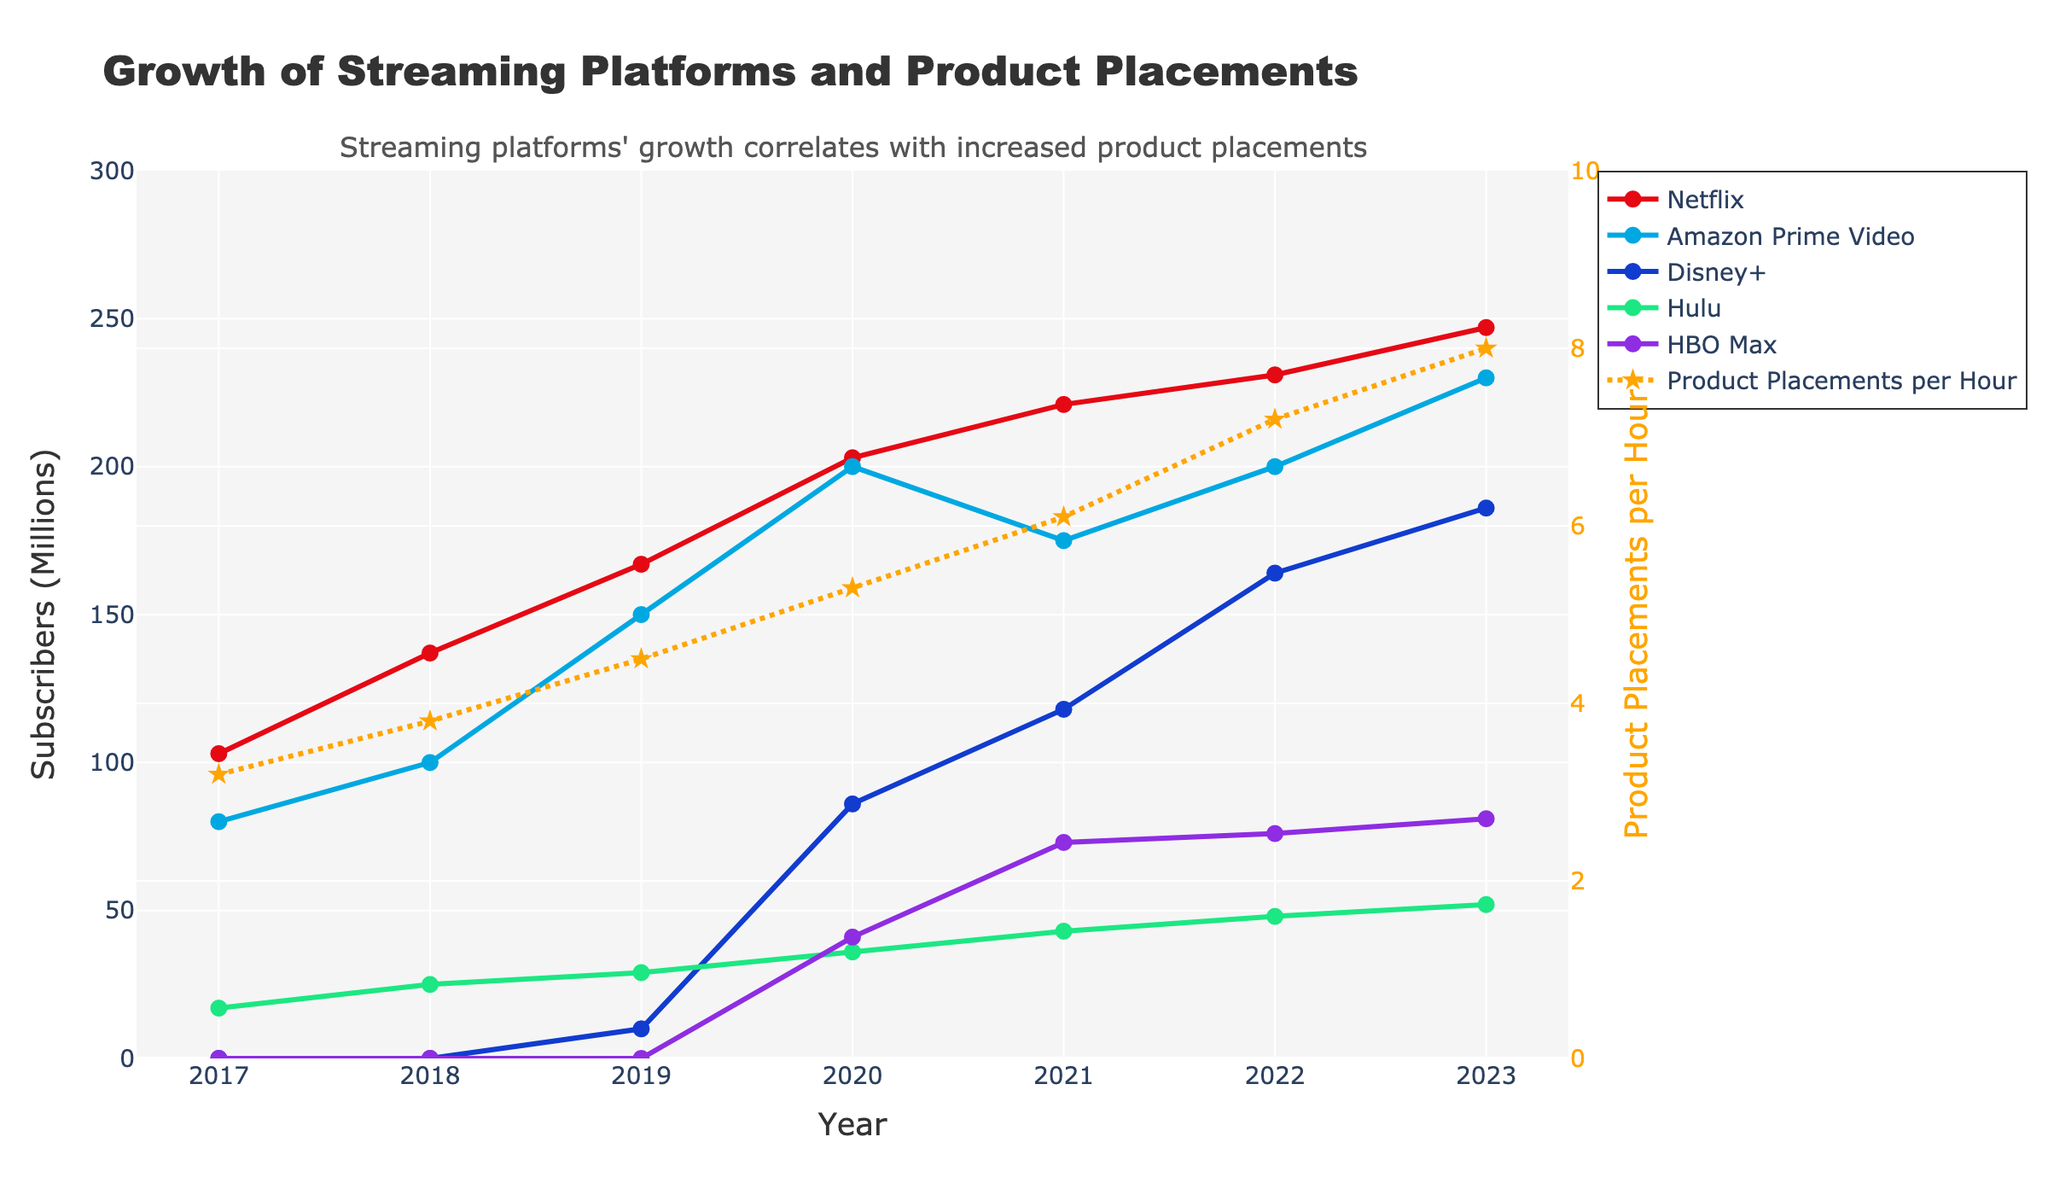What is the difference in Amazon Prime Video subscribers between 2017 and 2023? In 2017, Amazon Prime Video had 80 million subscribers, and in 2023, it had 230 million subscribers. The difference is calculated as 230 - 80 = 150.
Answer: 150 million Which streaming platform had the highest subscriber growth between 2020 and 2023? Between 2020 and 2023, Disney+ grew from 86 million to 186 million subscribers, showing an increase of 100 million. Comparing this growth with that of other platforms in the same period, Disney+ had the highest subscriber growth.
Answer: Disney+ In which year did Hulu surpass 40 million subscribers? Referring to the line chart, Hulu surpassed 40 million subscribers in the year 2021.
Answer: 2021 In 2023, how many more Netflix subscribers are there compared to HBO Max subscribers? In 2023, Netflix had 247 million subscribers and HBO Max had 81 million. The difference is calculated as 247 - 81 = 166.
Answer: 166 million What is the average yearly increase in Product Placements per Hour from 2017 to 2023? The product placements per hour increased from 3.2 in 2017 to 8.0 in 2023. The total increase over these 6 years (2023 - 2017) is 8.0 - 3.2 = 4.8. The average yearly increase is 4.8 / 6 = 0.8.
Answer: 0.8 How does the subscriber trend of Disney+ compare to that of Hulu from 2019 to 2023? Disney+ started with 10 million subscribers in 2019 and reached 186 million in 2023, displaying a rapid growth. Hulu grew from 29 million to 52 million over the same period, which is significantly slower. Comparatively, Disney+ had a much steeper increase in subscribers.
Answer: Disney+ had a much steeper increase In which year did Netflix reach over 200 million subscribers for the first time? According to the figure, Netflix reached over 200 million subscribers for the first time in 2020.
Answer: 2020 Does the trend of Product Placements per Hour align with the growth of streaming platform subscribers from 2017 to 2023? The figure shows that as the number of subscribers for streaming platforms increased from 2017 to 2023, the product placements per hour also increased from 3.2 to 8.0, indicating a positive correlation between subscriber growth and product placements.
Answer: Yes 